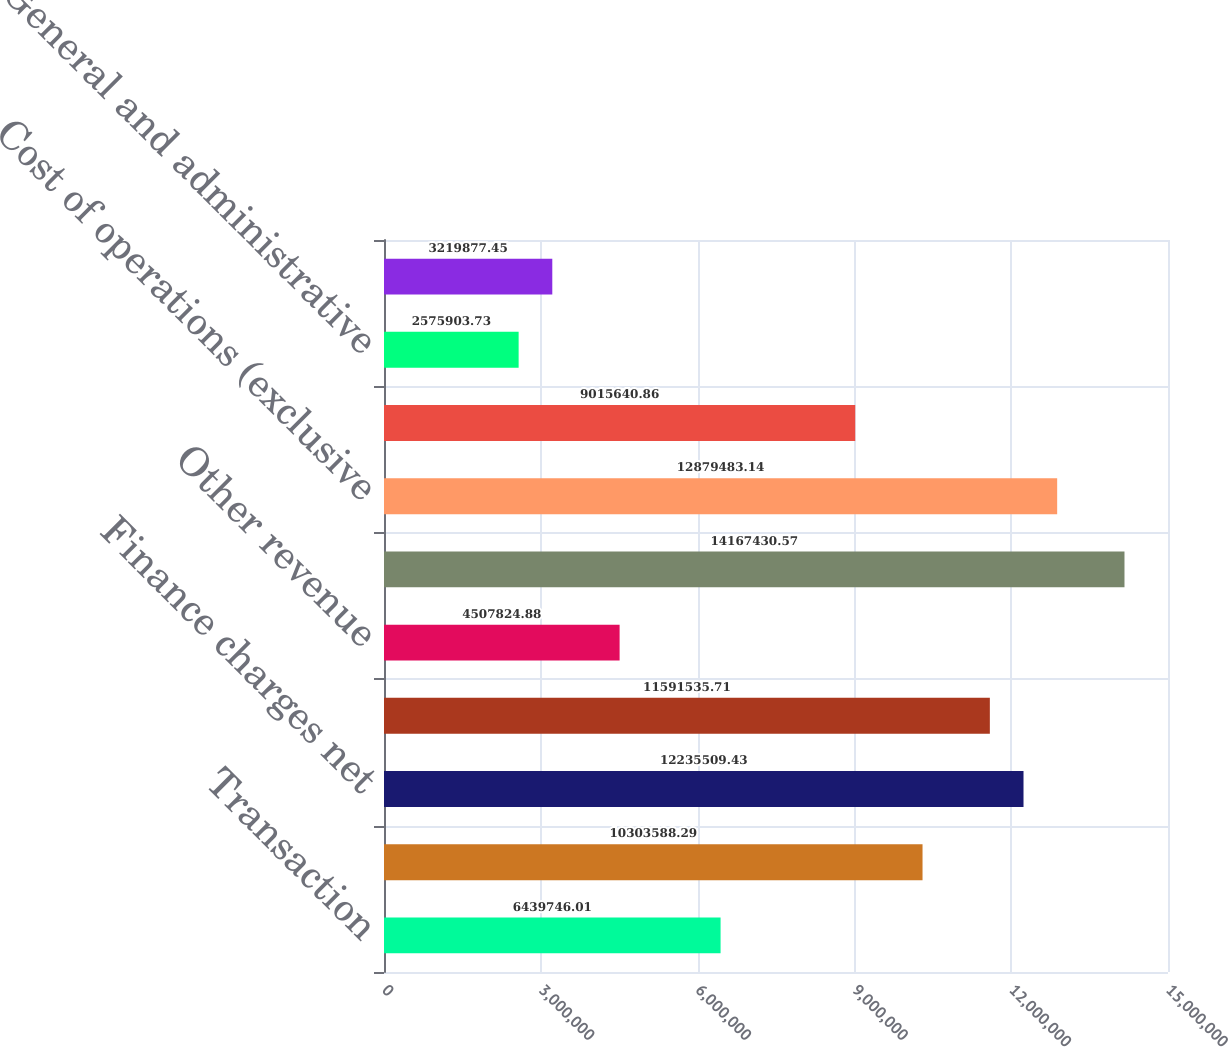<chart> <loc_0><loc_0><loc_500><loc_500><bar_chart><fcel>Transaction<fcel>Redemption<fcel>Finance charges net<fcel>Marketing services<fcel>Other revenue<fcel>Total revenue<fcel>Cost of operations (exclusive<fcel>Provision for loan loss<fcel>General and administrative<fcel>Depreciation and other<nl><fcel>6.43975e+06<fcel>1.03036e+07<fcel>1.22355e+07<fcel>1.15915e+07<fcel>4.50782e+06<fcel>1.41674e+07<fcel>1.28795e+07<fcel>9.01564e+06<fcel>2.5759e+06<fcel>3.21988e+06<nl></chart> 